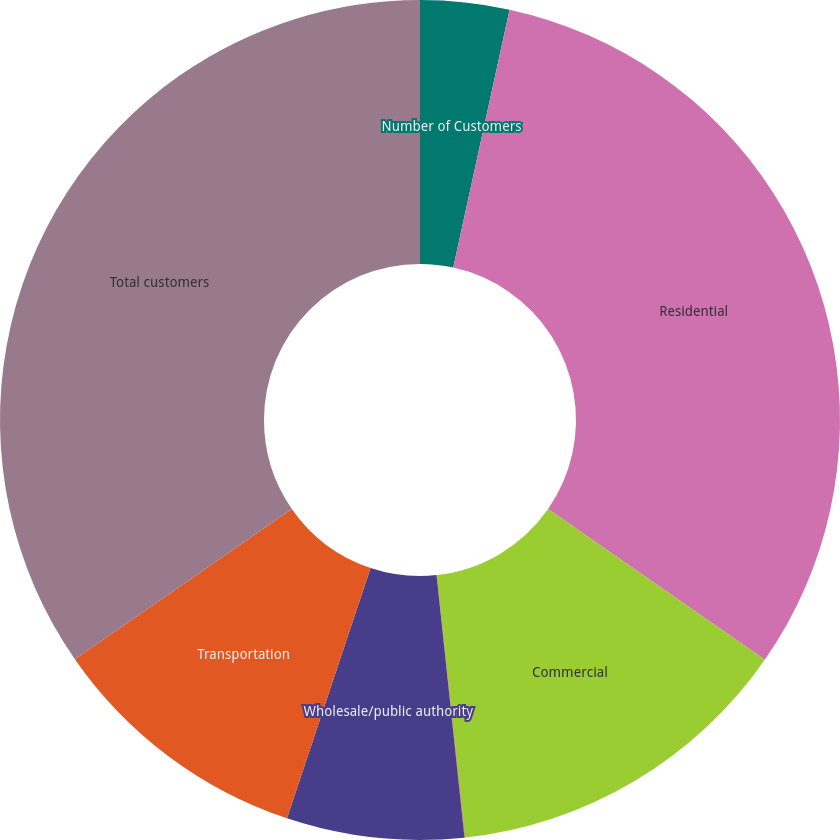Convert chart to OTSL. <chart><loc_0><loc_0><loc_500><loc_500><pie_chart><fcel>Number of Customers<fcel>Residential<fcel>Commercial<fcel>Industrial<fcel>Wholesale/public authority<fcel>Transportation<fcel>Total customers<nl><fcel>3.42%<fcel>31.25%<fcel>13.62%<fcel>0.02%<fcel>6.82%<fcel>10.22%<fcel>34.65%<nl></chart> 